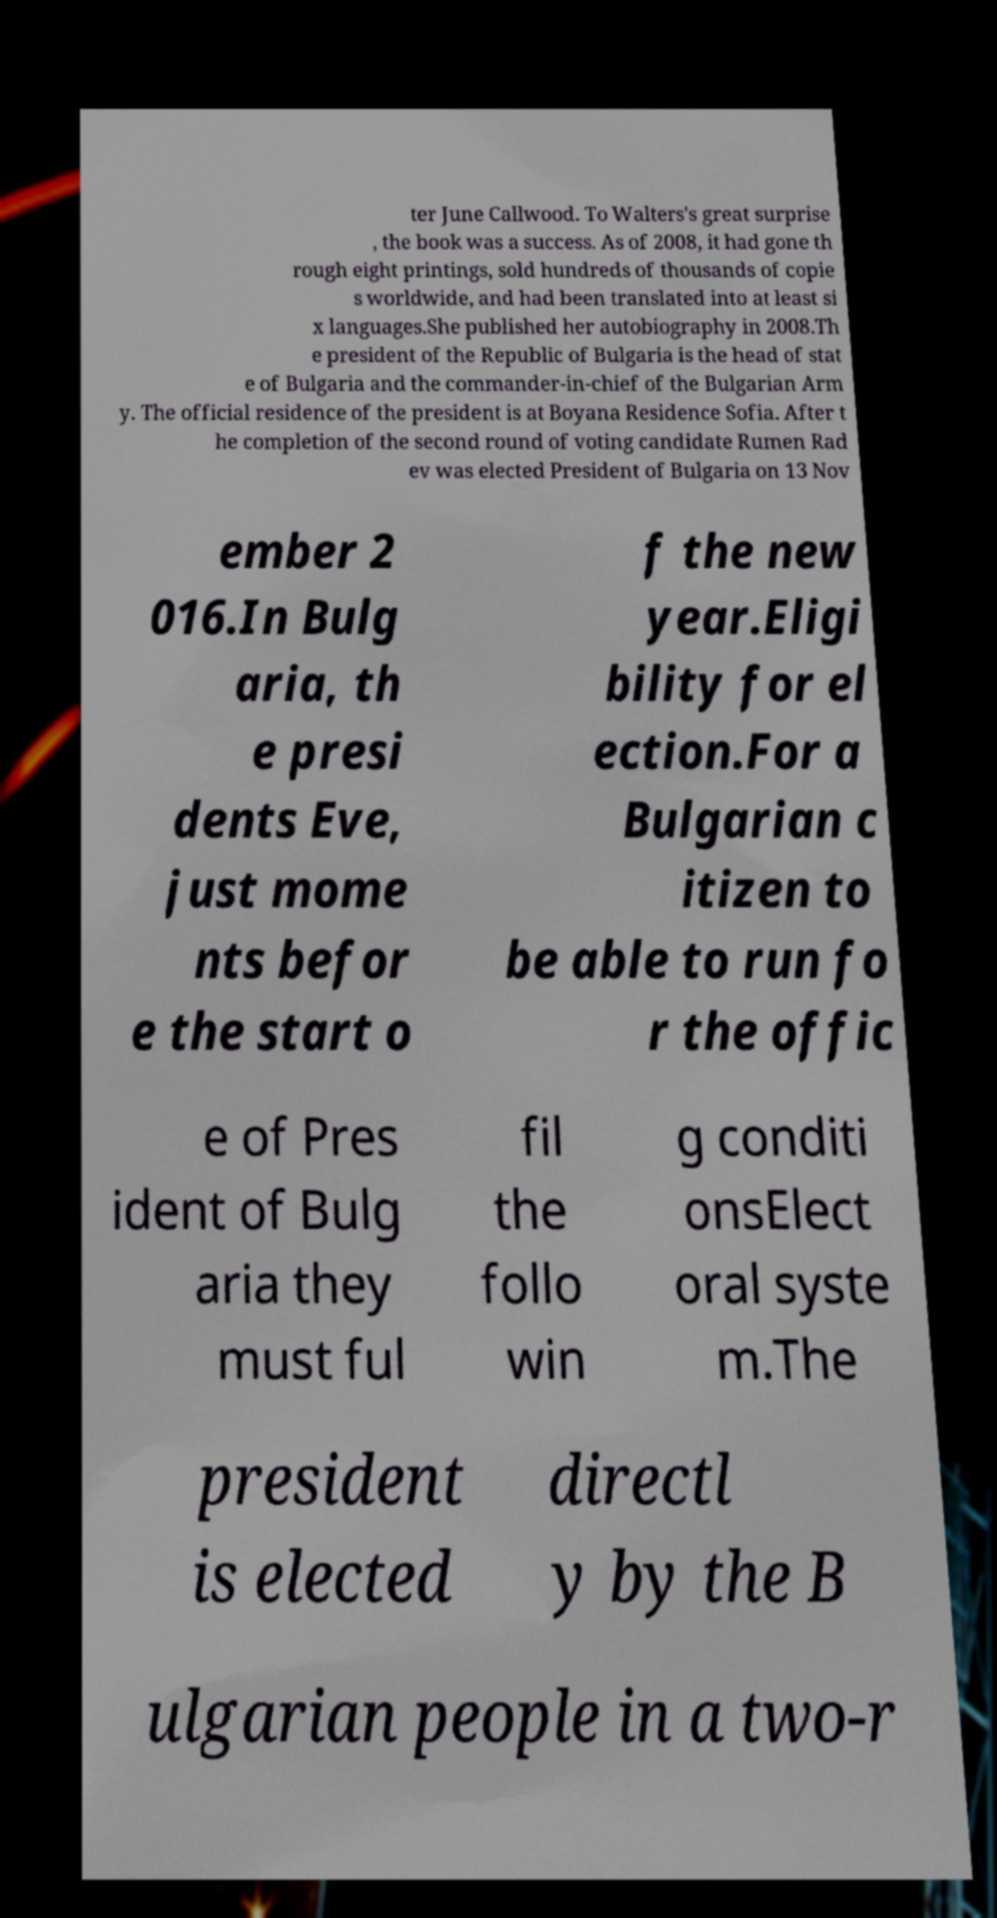Could you extract and type out the text from this image? ter June Callwood. To Walters's great surprise , the book was a success. As of 2008, it had gone th rough eight printings, sold hundreds of thousands of copie s worldwide, and had been translated into at least si x languages.She published her autobiography in 2008.Th e president of the Republic of Bulgaria is the head of stat e of Bulgaria and the commander-in-chief of the Bulgarian Arm y. The official residence of the president is at Boyana Residence Sofia. After t he completion of the second round of voting candidate Rumen Rad ev was elected President of Bulgaria on 13 Nov ember 2 016.In Bulg aria, th e presi dents Eve, just mome nts befor e the start o f the new year.Eligi bility for el ection.For a Bulgarian c itizen to be able to run fo r the offic e of Pres ident of Bulg aria they must ful fil the follo win g conditi onsElect oral syste m.The president is elected directl y by the B ulgarian people in a two-r 